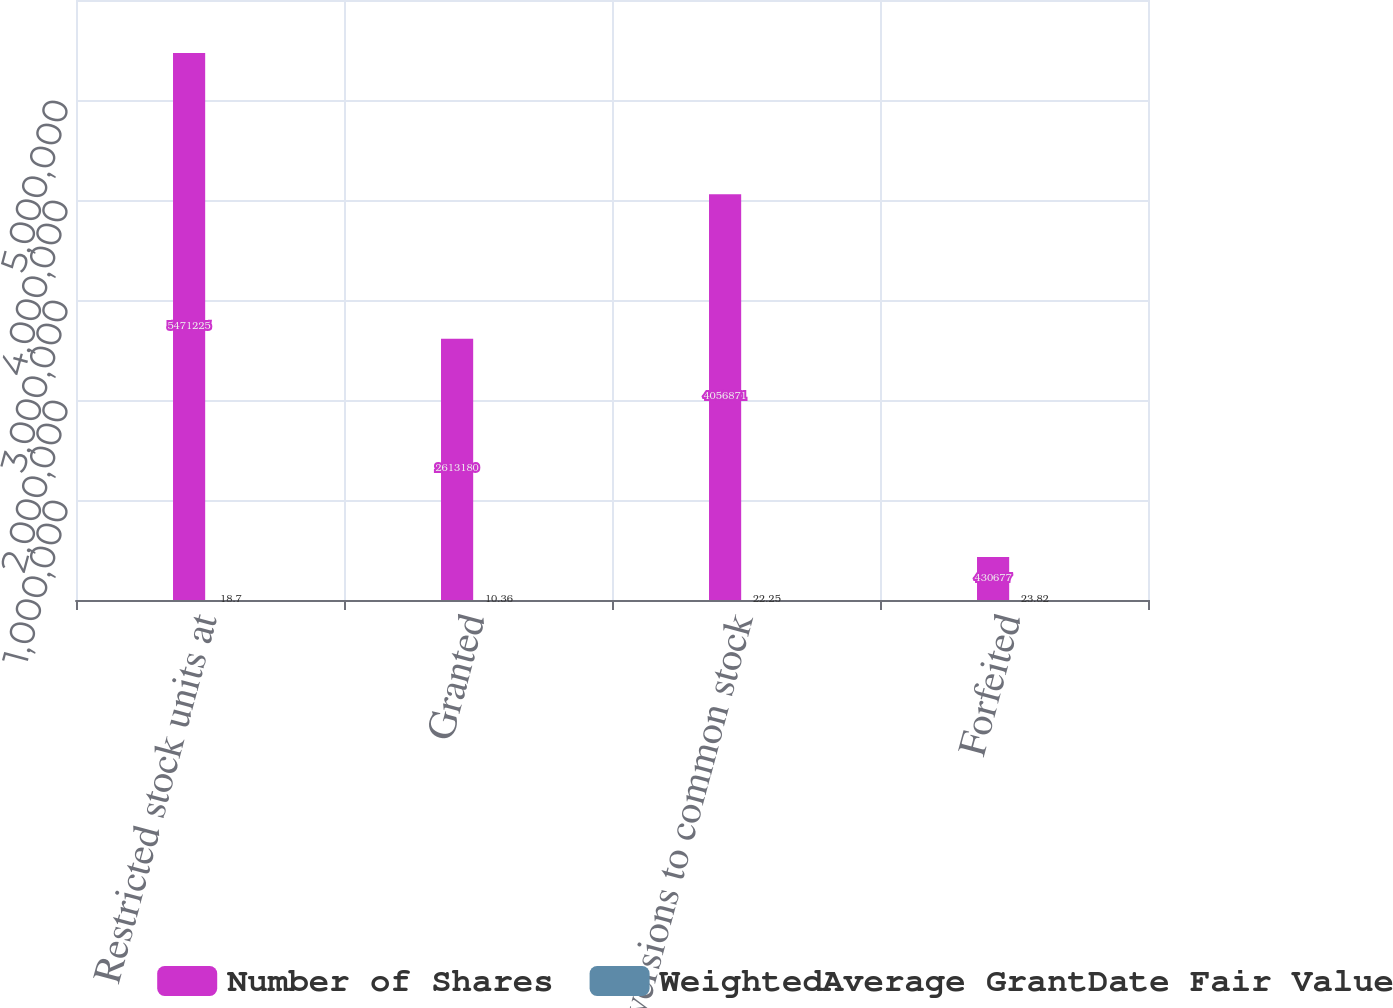Convert chart. <chart><loc_0><loc_0><loc_500><loc_500><stacked_bar_chart><ecel><fcel>Restricted stock units at<fcel>Granted<fcel>Conversions to common stock<fcel>Forfeited<nl><fcel>Number of Shares<fcel>5.47122e+06<fcel>2.61318e+06<fcel>4.05687e+06<fcel>430677<nl><fcel>WeightedAverage GrantDate Fair Value<fcel>18.7<fcel>10.36<fcel>22.25<fcel>23.82<nl></chart> 